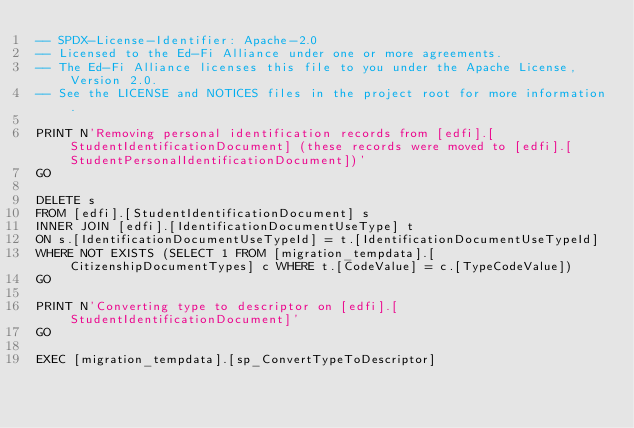<code> <loc_0><loc_0><loc_500><loc_500><_SQL_>-- SPDX-License-Identifier: Apache-2.0
-- Licensed to the Ed-Fi Alliance under one or more agreements.
-- The Ed-Fi Alliance licenses this file to you under the Apache License, Version 2.0.
-- See the LICENSE and NOTICES files in the project root for more information.

PRINT N'Removing personal identification records from [edfi].[StudentIdentificationDocument] (these records were moved to [edfi].[StudentPersonalIdentificationDocument])'
GO

DELETE s
FROM [edfi].[StudentIdentificationDocument] s
INNER JOIN [edfi].[IdentificationDocumentUseType] t
ON s.[IdentificationDocumentUseTypeId] = t.[IdentificationDocumentUseTypeId]
WHERE NOT EXISTS (SELECT 1 FROM [migration_tempdata].[CitizenshipDocumentTypes] c WHERE t.[CodeValue] = c.[TypeCodeValue])
GO

PRINT N'Converting type to descriptor on [edfi].[StudentIdentificationDocument]'
GO

EXEC [migration_tempdata].[sp_ConvertTypeToDescriptor]</code> 